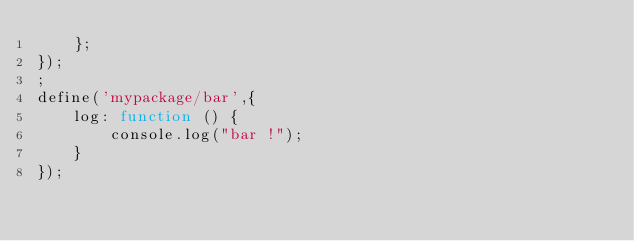Convert code to text. <code><loc_0><loc_0><loc_500><loc_500><_JavaScript_>	};
});
;
define('mypackage/bar',{
	log: function () {
		console.log("bar !");
	}
});
</code> 